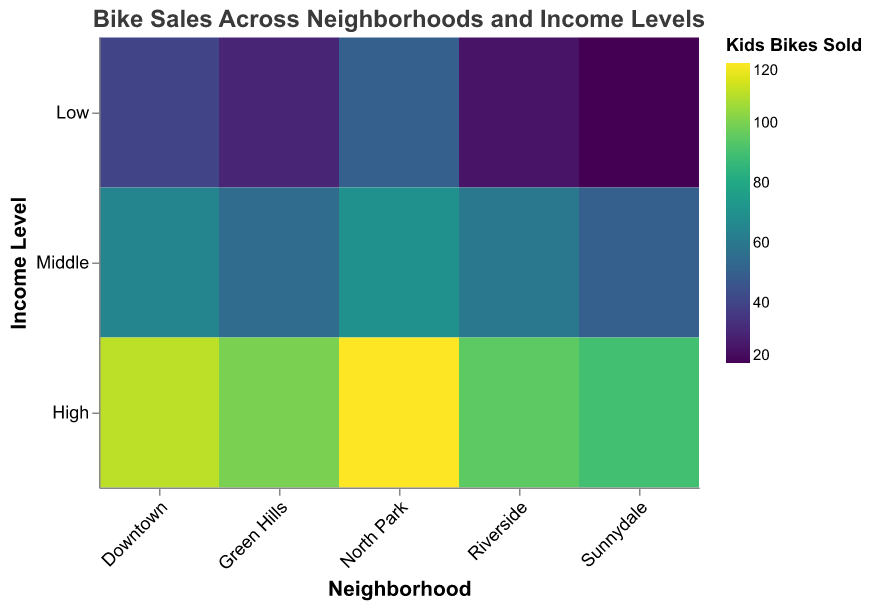What does the title of the heatmap say? The title of the heatmap is displayed at the top and it gives an overview of the data presented. It reads "Bike Sales Across Neighborhoods and Income Levels".
Answer: "Bike Sales Across Neighborhoods and Income Levels" How is the x-axis labeled? The x-axis represents different neighborhoods. It is labeled with neighborhood names such as "North Park", "Downtown", "Green Hills", "Sunnydale", and "Riverside".
Answer: Neighborhood Which neighborhood has the highest number of kids' bikes sold at high income levels? On the heatmap, find the cell corresponding to the high income level for each neighborhood and compare the color intensity or tooltip information for "Kids Bikes Sold". "North Park" has the highest number of kids' bikes sold at high income levels, indicated by the darkest color and tooltip showing 120 bikes sold.
Answer: North Park Where are the lowest kids' bike sales observed? Examine the heatmap for the cell that is the lightest in color, which indicates the lowest number of kids' bikes sold. The tooltip can also be used to confirm this. The lowest sales are seen in Sunnydale with the low income level, where 20 kids' bikes were sold.
Answer: Sunnydale (Low income level) Which income level generally corresponds to higher bike sales across all neighborhoods? Compare the color intensity of cells across different income levels (Low, Middle, High) for all neighborhoods. Generally, the cells corresponding to the high income level are darker, indicating a higher number of bikes sold.
Answer: High By how much does the number of adult bikes sold increase from low to high income levels in Downtown? Look at the cells for Downtown at low and high income levels. Tooltip shows 15 adult bikes sold at low and 55 adult bikes sold at high income levels. The increase is 55 - 15 = 40 bikes.
Answer: 40 Which neighborhood has the smallest difference in kids' bike sales between low and high income levels? Calculate the difference in kids' bike sales between low and high income levels for each neighborhood. The differences are: North Park (70), Downtown (70), Green Hills (70), Sunnydale (70), Riverside (70). All neighborhoods have the same difference of 70.
Answer: All neighborhoods (difference of 70) What is the average number of kids' bikes sold at middle income levels across all neighborhoods? Identify the number of kids' bikes sold at middle income levels for each neighborhood: North Park (70), Downtown (65), Green Hills (55), Sunnydale (50), Riverside (60). The average = (70 + 65 + 55 + 50 + 60) / 5 = 60.
Answer: 60 Compare the kids' bike sales between North Park and Riverside at middle income levels. Which neighborhood has more sales and by how much? Look at the kids' bike sales for North Park and Riverside at middle income levels: North Park (70), Riverside (60). North Park has more sales by 70 - 60 = 10 bikes.
Answer: North Park by 10 In general, do neighborhoods with higher incomes have darker cells for kids' bike sales, lighter cells, or is there no clear pattern? Observe the color intensity related to kids' bike sales for high income levels across neighborhoods. Generally, cells for higher income levels are darker, indicating higher sales.
Answer: Darker cells 